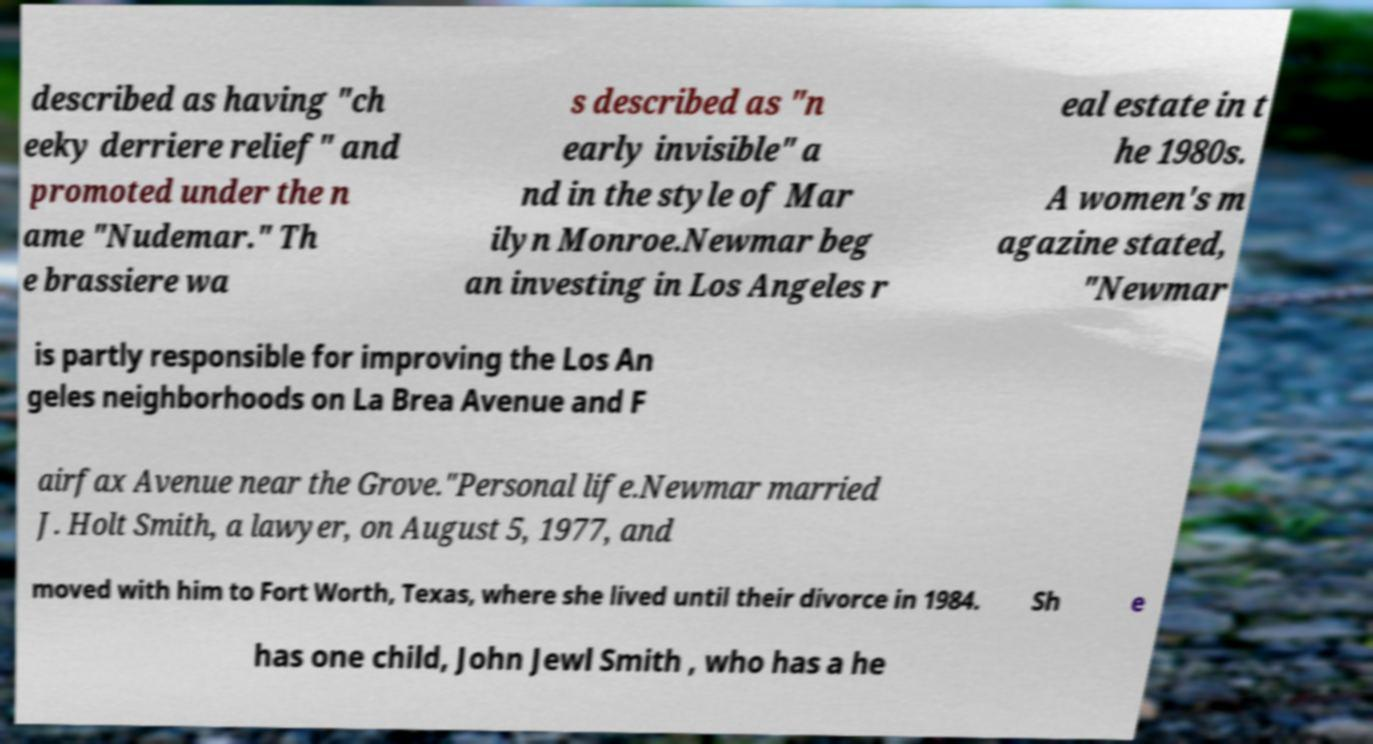What messages or text are displayed in this image? I need them in a readable, typed format. described as having "ch eeky derriere relief" and promoted under the n ame "Nudemar." Th e brassiere wa s described as "n early invisible" a nd in the style of Mar ilyn Monroe.Newmar beg an investing in Los Angeles r eal estate in t he 1980s. A women's m agazine stated, "Newmar is partly responsible for improving the Los An geles neighborhoods on La Brea Avenue and F airfax Avenue near the Grove."Personal life.Newmar married J. Holt Smith, a lawyer, on August 5, 1977, and moved with him to Fort Worth, Texas, where she lived until their divorce in 1984. Sh e has one child, John Jewl Smith , who has a he 